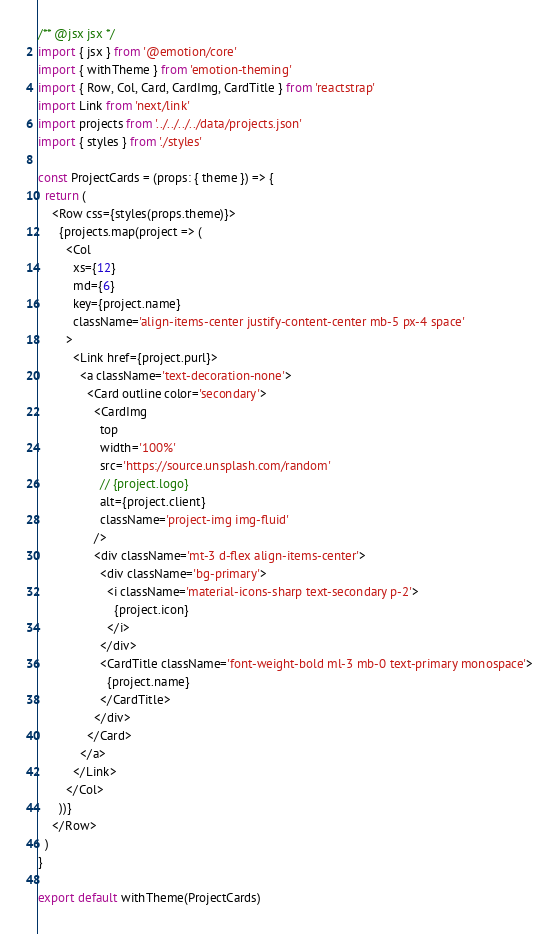Convert code to text. <code><loc_0><loc_0><loc_500><loc_500><_TypeScript_>/** @jsx jsx */
import { jsx } from '@emotion/core'
import { withTheme } from 'emotion-theming'
import { Row, Col, Card, CardImg, CardTitle } from 'reactstrap'
import Link from 'next/link'
import projects from '../../../../data/projects.json'
import { styles } from './styles'

const ProjectCards = (props: { theme }) => {
  return (
    <Row css={styles(props.theme)}>
      {projects.map(project => (
        <Col
          xs={12}
          md={6}
          key={project.name}
          className='align-items-center justify-content-center mb-5 px-4 space'
        >
          <Link href={project.purl}>
            <a className='text-decoration-none'>
              <Card outline color='secondary'>
                <CardImg
                  top
                  width='100%'
                  src='https://source.unsplash.com/random'
                  // {project.logo}
                  alt={project.client}
                  className='project-img img-fluid'
                />
                <div className='mt-3 d-flex align-items-center'>
                  <div className='bg-primary'>
                    <i className='material-icons-sharp text-secondary p-2'>
                      {project.icon}
                    </i>
                  </div>
                  <CardTitle className='font-weight-bold ml-3 mb-0 text-primary monospace'>
                    {project.name}
                  </CardTitle>
                </div>
              </Card>
            </a>
          </Link>
        </Col>
      ))}
    </Row>
  )
}

export default withTheme(ProjectCards)
</code> 